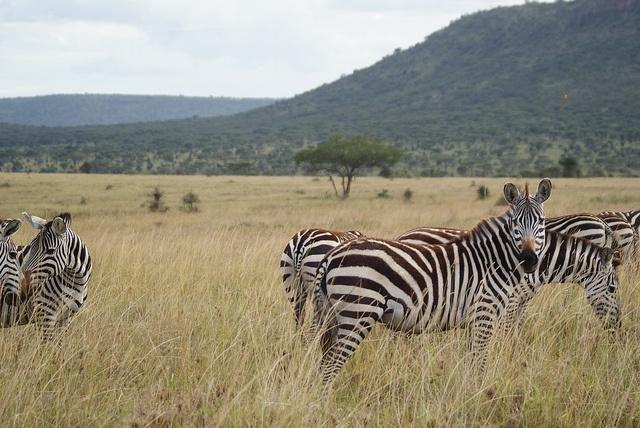Describe the objects in this image and their specific colors. I can see zebra in lightgray, black, darkgray, gray, and tan tones, zebra in lightgray, gray, black, tan, and darkgray tones, zebra in lightgray, black, darkgray, tan, and gray tones, zebra in lightgray, black, gray, tan, and darkgray tones, and zebra in lightgray, black, gray, and darkgray tones in this image. 